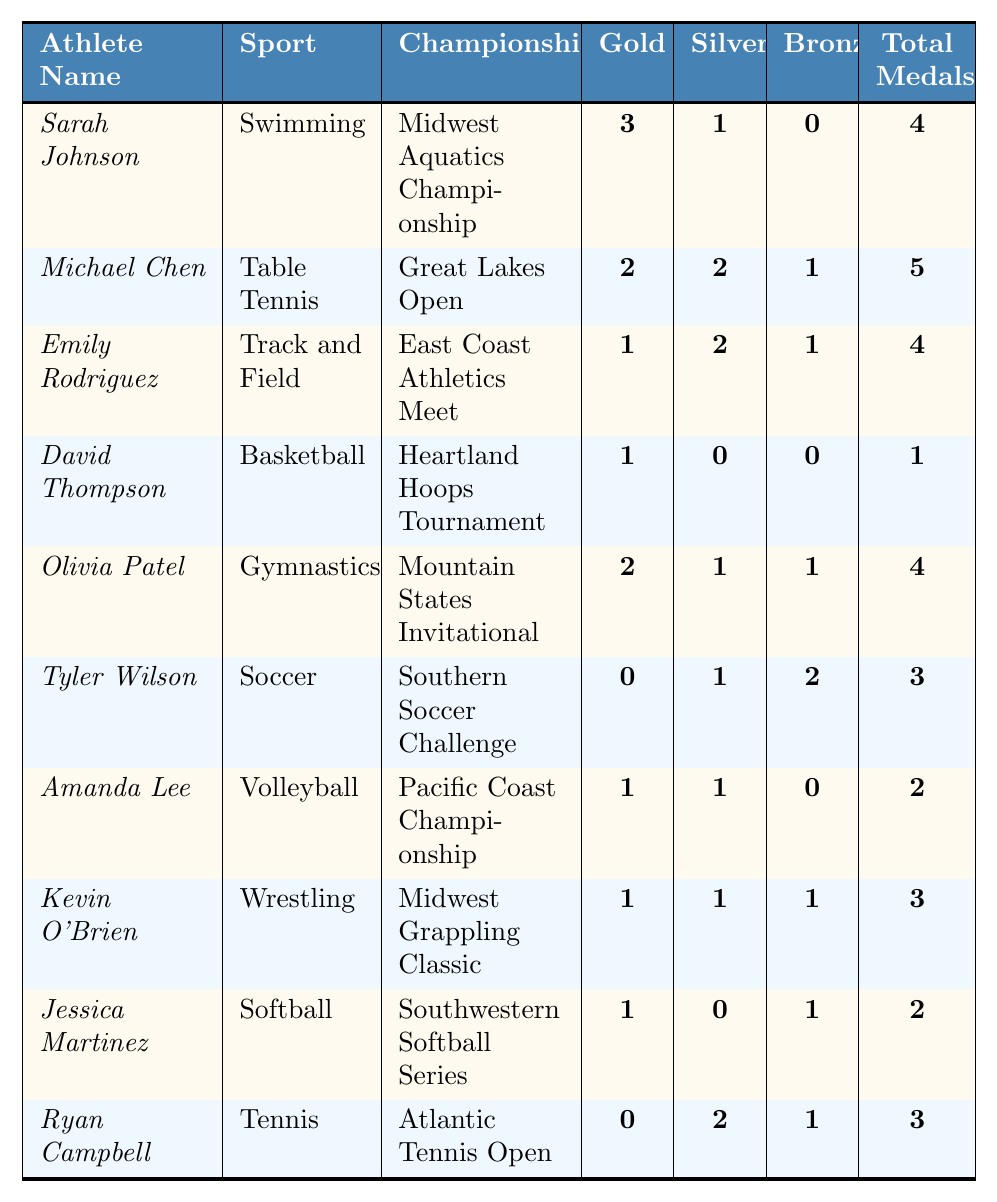What is the total number of medals won by Sarah Johnson? Sarah Johnson has a total of 4 medals listed under "Total Medals" in the table.
Answer: 4 Which athlete won the most gold medals? Michael Chen won the most gold medals with a total of 2.
Answer: Michael Chen How many athletes won more silver medals than gold medals? By checking the "Silver" and "Gold" columns, both Emily Rodriguez, Tyler Wilson, and Kevin O'Brien won more silver (2, 1, and 1 respectively) than gold (1, 0, and 1). Therefore, 3 athletes meet this criterion.
Answer: 3 What is the average number of total medals won by the athletes? To find the average, sum the "Total Medals" (4 + 5 + 4 + 1 + 4 + 3 + 2 + 3 + 2 + 3 = 33) and divide by the number of athletes (10). Thus, the average is 33 / 10 = 3.3.
Answer: 3.3 Did any athlete win all their medals in a single championship? The data shows each athlete's medals are from different championships; for instance, Sarah Johnson and Michael Chen have medals from distinct events. Therefore, no athlete won all their medals in a single championship.
Answer: No Which sport has the highest total medal count? Sum the total medals per sport: Swimming (4), Table Tennis (5), Track and Field (4), Basketball (1), Gymnastics (4), Soccer (3), Volleyball (2), Wrestling (3), Softball (2), Tennis (3). Table Tennis has the highest total at 5.
Answer: Table Tennis How many athletes have a total medal count of 2? Jessica Martinez and Amanda Lee each have 2 total medals, making a total of 2 athletes with this count.
Answer: 2 Which athlete participated in the Heartland Hoops Tournament? David Thompson participated in the Heartland Hoops Tournament, as referenced in the "Championship" column.
Answer: David Thompson What is the total count of bronze medals won across all athletes? Adding the bronze medals (0 + 1 + 1 + 0 + 1 + 2 + 0 + 1 + 1 + 1 = 8) gives a total of 8 bronze medals won by all athletes.
Answer: 8 Which athlete has a higher total medal count, Olivia Patel or Ryan Campbell? Olivia Patel has 4 total medals while Ryan Campbell has 3; therefore, Olivia Patel has a higher total medal count.
Answer: Olivia Patel 